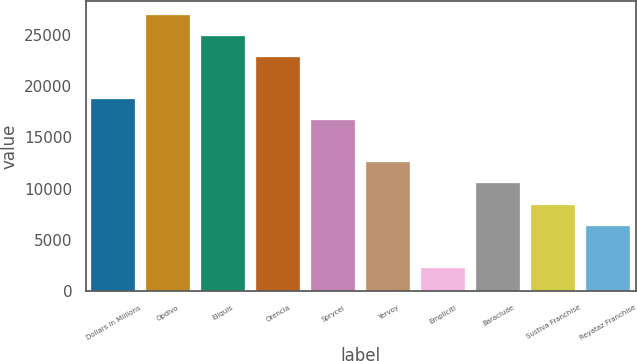Convert chart to OTSL. <chart><loc_0><loc_0><loc_500><loc_500><bar_chart><fcel>Dollars in Millions<fcel>Opdivo<fcel>Eliquis<fcel>Orencia<fcel>Sprycel<fcel>Yervoy<fcel>Empliciti<fcel>Baraclude<fcel>Sustiva Franchise<fcel>Reyataz Franchise<nl><fcel>18720.8<fcel>26941.6<fcel>24886.4<fcel>22831.2<fcel>16665.6<fcel>12555.2<fcel>2279.2<fcel>10500<fcel>8444.8<fcel>6389.6<nl></chart> 